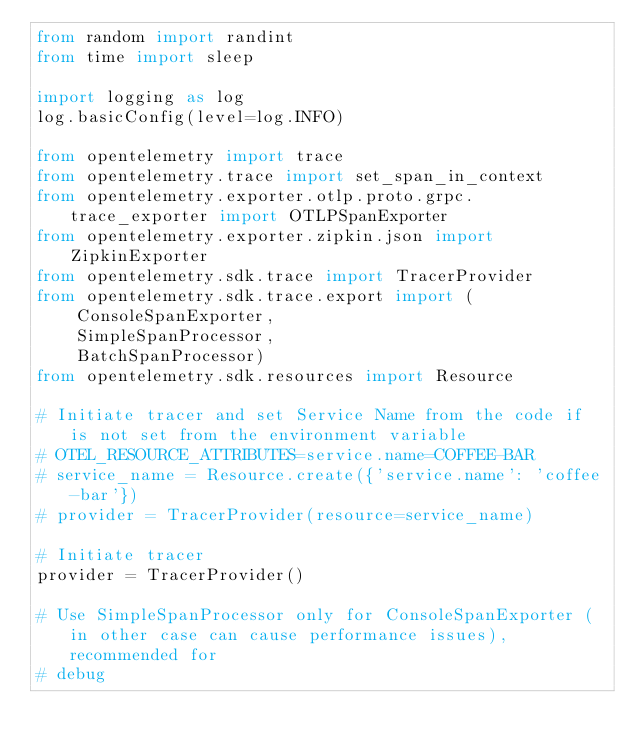<code> <loc_0><loc_0><loc_500><loc_500><_Python_>from random import randint
from time import sleep

import logging as log
log.basicConfig(level=log.INFO)

from opentelemetry import trace
from opentelemetry.trace import set_span_in_context
from opentelemetry.exporter.otlp.proto.grpc.trace_exporter import OTLPSpanExporter
from opentelemetry.exporter.zipkin.json import ZipkinExporter
from opentelemetry.sdk.trace import TracerProvider
from opentelemetry.sdk.trace.export import (
    ConsoleSpanExporter,
    SimpleSpanProcessor,
    BatchSpanProcessor)
from opentelemetry.sdk.resources import Resource

# Initiate tracer and set Service Name from the code if is not set from the environment variable
# OTEL_RESOURCE_ATTRIBUTES=service.name=COFFEE-BAR
# service_name = Resource.create({'service.name': 'coffee-bar'})
# provider = TracerProvider(resource=service_name)

# Initiate tracer
provider = TracerProvider()

# Use SimpleSpanProcessor only for ConsoleSpanExporter (in other case can cause performance issues), recommended for
# debug</code> 